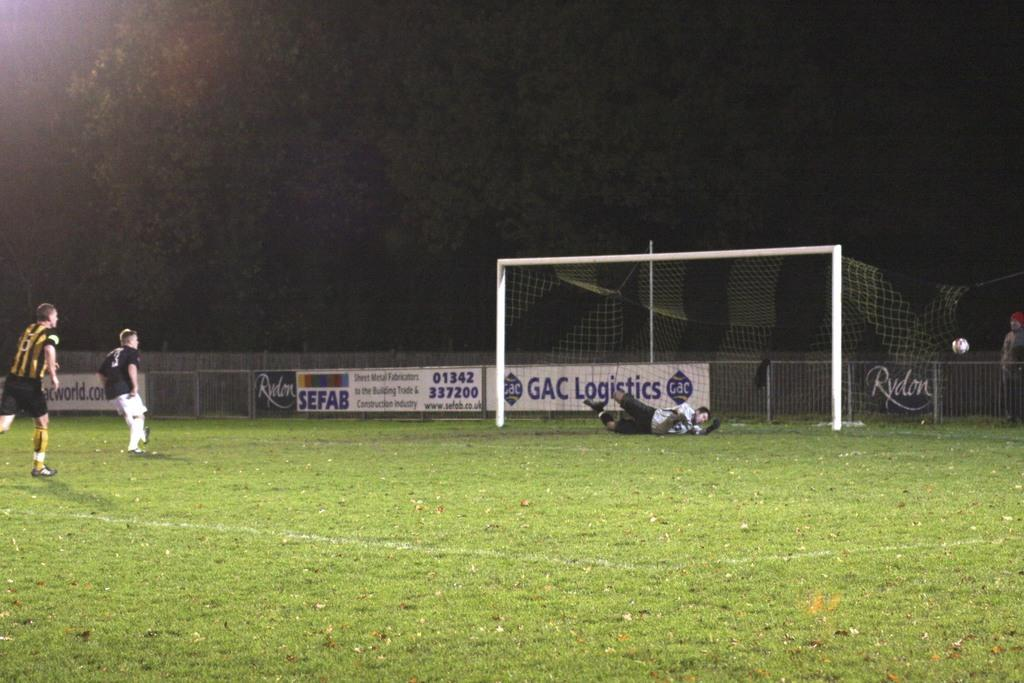Provide a one-sentence caption for the provided image. A soccer field with a Sefab banner on the fence in the background. 